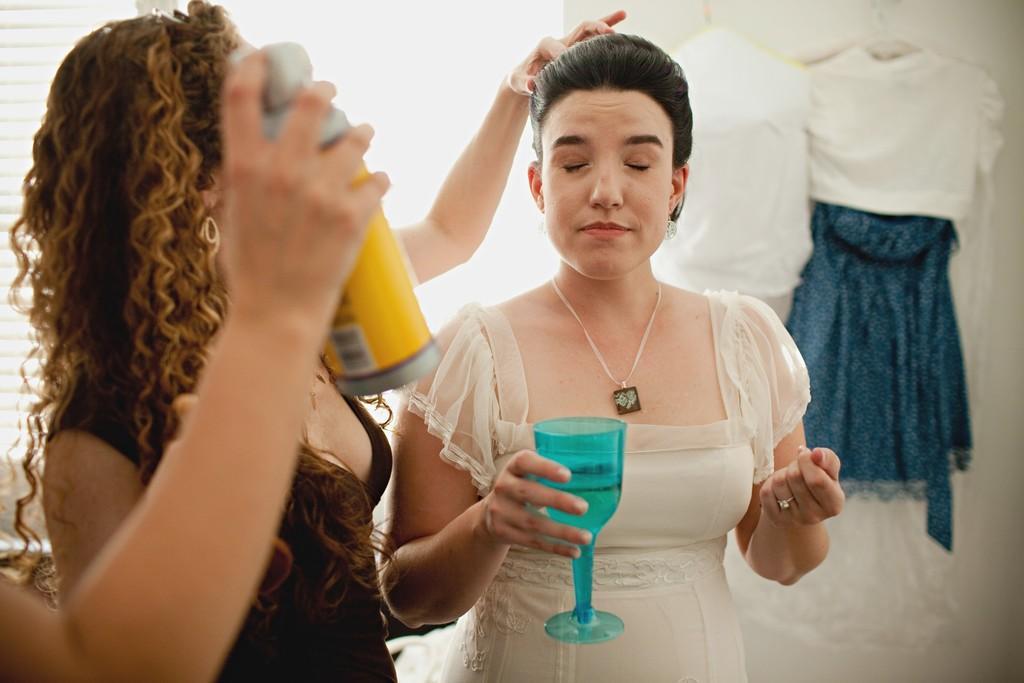Please provide a concise description of this image. in this image there are two persons. The person standing at the front is holding the bottle, the person with white is holding the glass. At the back there are dress hanging to the hanger. 